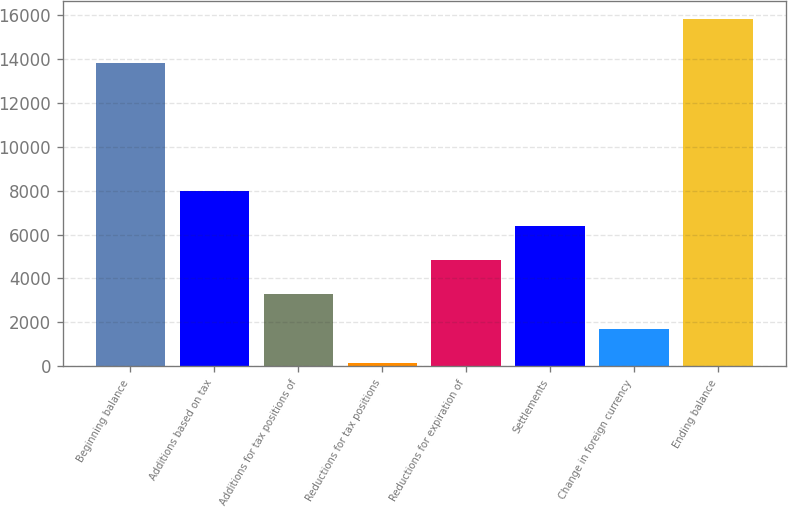Convert chart. <chart><loc_0><loc_0><loc_500><loc_500><bar_chart><fcel>Beginning balance<fcel>Additions based on tax<fcel>Additions for tax positions of<fcel>Reductions for tax positions<fcel>Reductions for expiration of<fcel>Settlements<fcel>Change in foreign currency<fcel>Ending balance<nl><fcel>13804<fcel>7980.5<fcel>3274.4<fcel>137<fcel>4843.1<fcel>6411.8<fcel>1705.7<fcel>15824<nl></chart> 